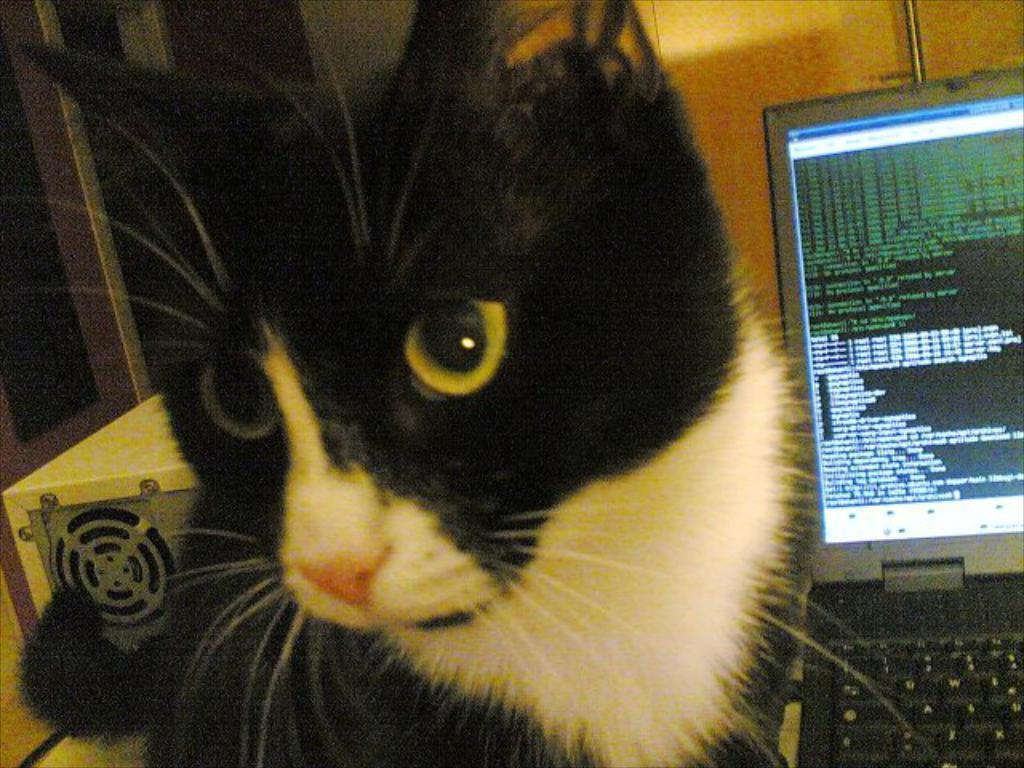What type of animal is in the image? There is a cat in the image. What electronic device is in the image? There is a laptop in the image. Can you describe the object in the image? There is an object in the image, but its specific nature is not mentioned in the facts. What can be seen in the background of the image? There is a wall and a window in the background of the image. How many teeth can be seen in the image? There is no mention of teeth in the image, so it is not possible to determine how many teeth are visible. 